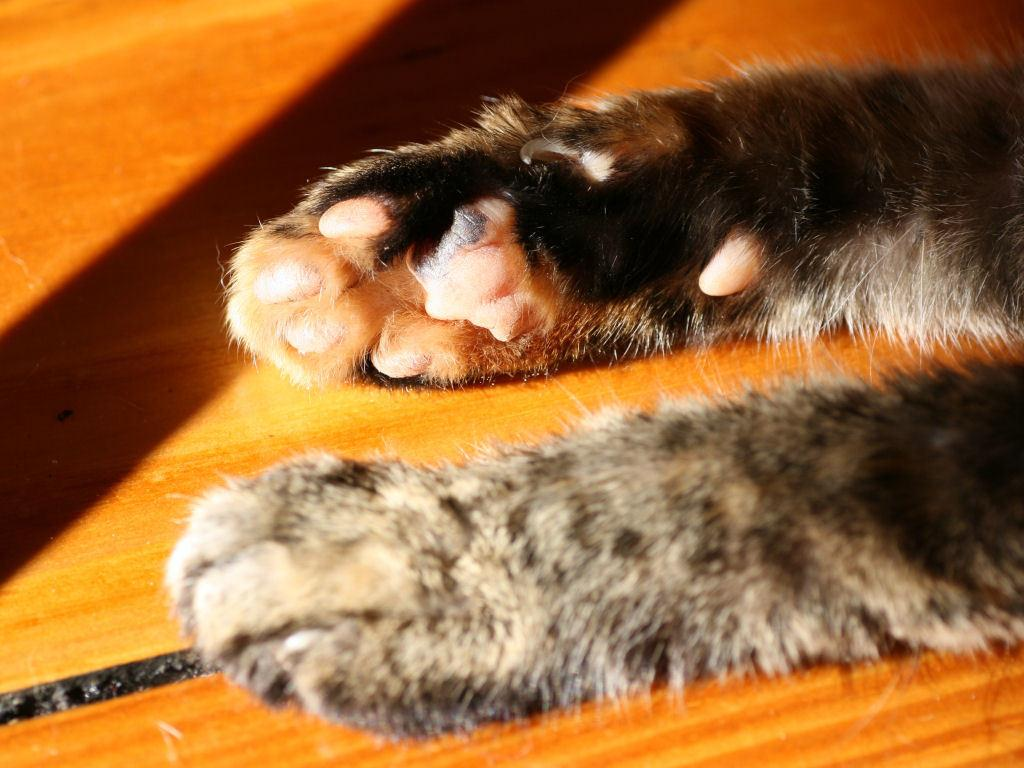What type of object is present in the image that belongs to an animal? There are legs of an animal in the image. Where are the legs of the animal positioned in the image? The legs of the animal are on a wooden desk. What can be seen in the image that indicates the presence of natural light? There is sunlight visible in the image. What type of record can be seen being played on the wooden desk in the image? There is no record present in the image; it features the legs of an animal on a wooden desk. How many knees are visible in the image? There are no knees visible in the image; it features the legs of an animal on a wooden desk. 